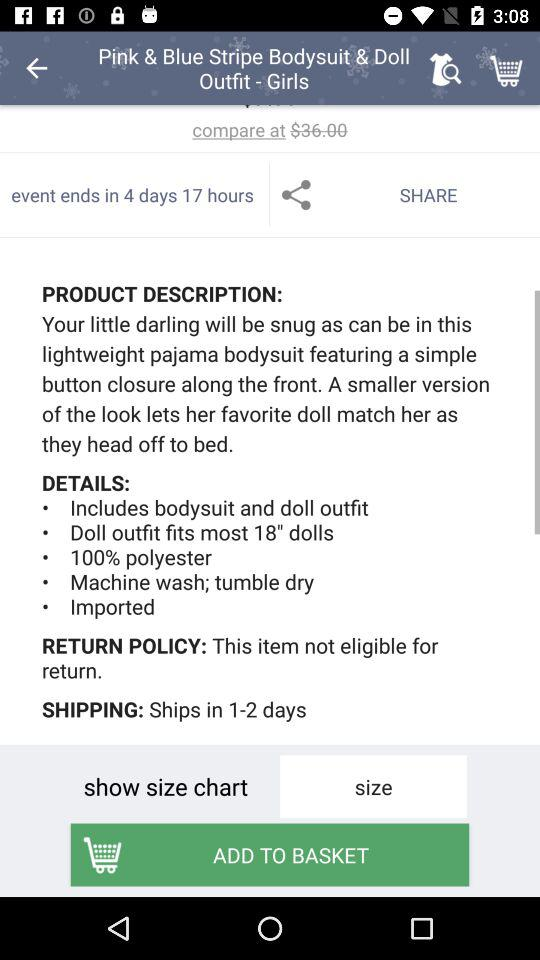In how many days will the product be shipped? The product will be shipped within 1-2 days. 